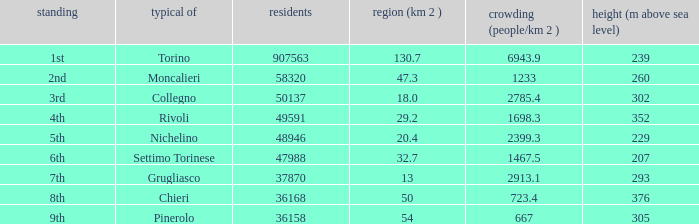What is the crowdedness level in the common of chieri? 723.4. 